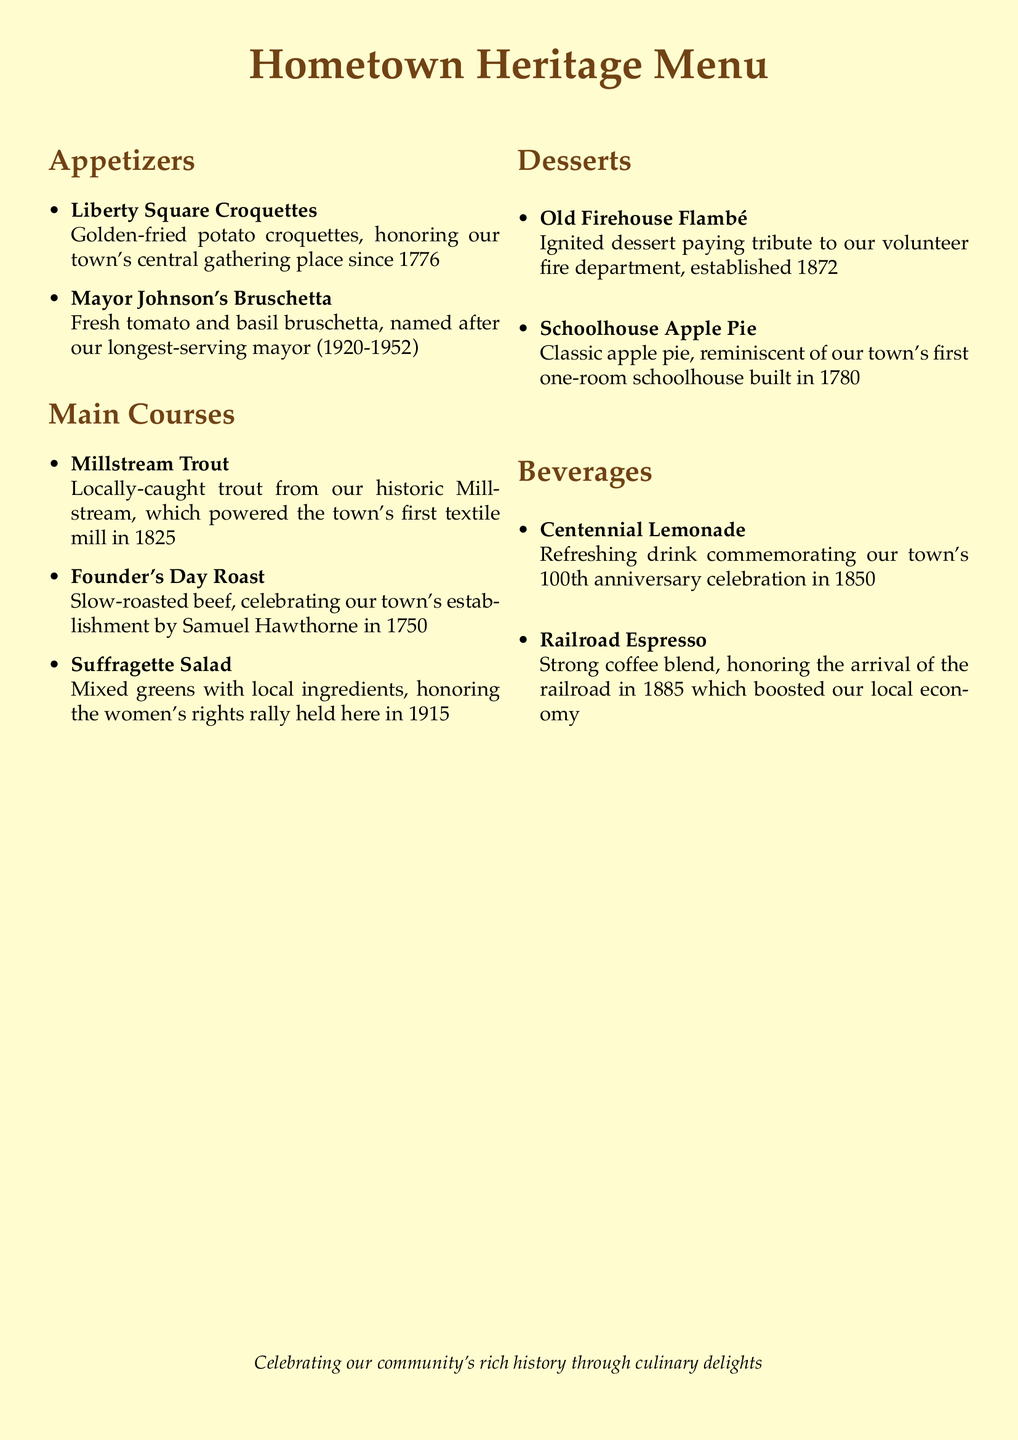What dish honors our town's central gathering place since 1776? The dish named after the town's central gathering place since 1776 is "Liberty Square Croquettes."
Answer: Liberty Square Croquettes Who is the dish "Mayor Johnson's Bruschetta" named after? The dish "Mayor Johnson's Bruschetta" is named after our longest-serving mayor, who served from 1920 to 1952.
Answer: Mayor Johnson What year was the town's first textile mill powered by Millstream Trout established? The Millstream powered the town's first textile mill in 1825, which is highlighted in the dish "Millstream Trout."
Answer: 1825 What is the significance of the dish "Suffragette Salad"? "Suffragette Salad" honors the women's rights rally held in 1915, connecting the dish to an important historical event.
Answer: Women's rights rally of 1915 Which dessert pays tribute to the volunteer fire department? The dessert that pays tribute to the volunteer fire department is "Old Firehouse Flambé."
Answer: Old Firehouse Flambé What beverage commemorates the town's 100th anniversary celebration? The beverage that commemorates the town's 100th anniversary is "Centennial Lemonade."
Answer: Centennial Lemonade Which main course celebrates the establishment of the town by Samuel Hawthorne? The main course that celebrates the establishment of the town is "Founder's Day Roast."
Answer: Founder's Day Roast What type of document is being described here? The document describes a restaurant menu that reflects the community's heritage through dishes.
Answer: Restaurant menu 